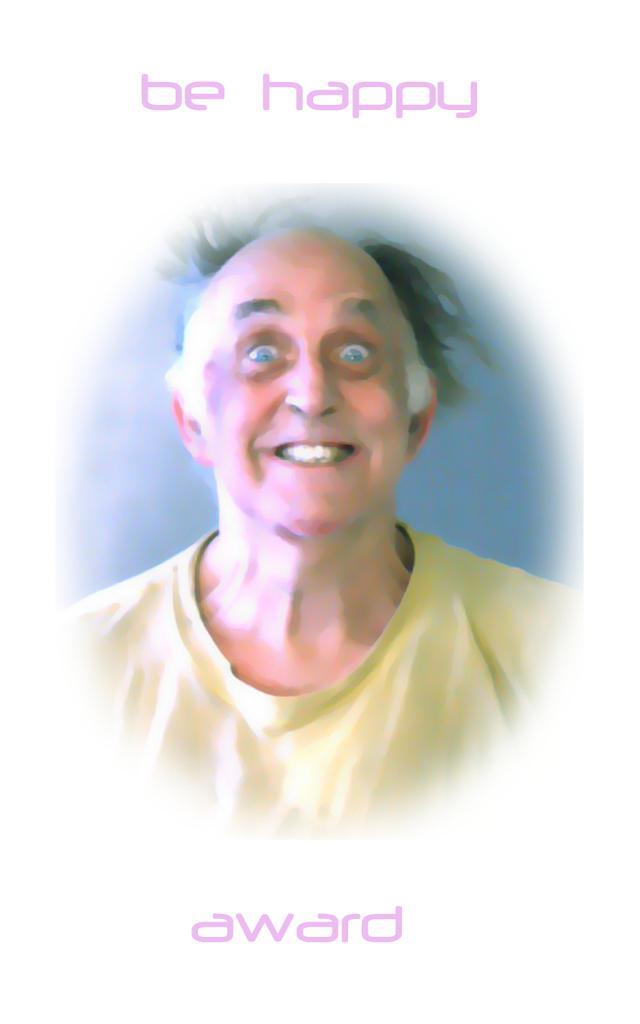Could you give a brief overview of what you see in this image? In this image it might be a painting of person and at the top and bottom there is a text visible. 